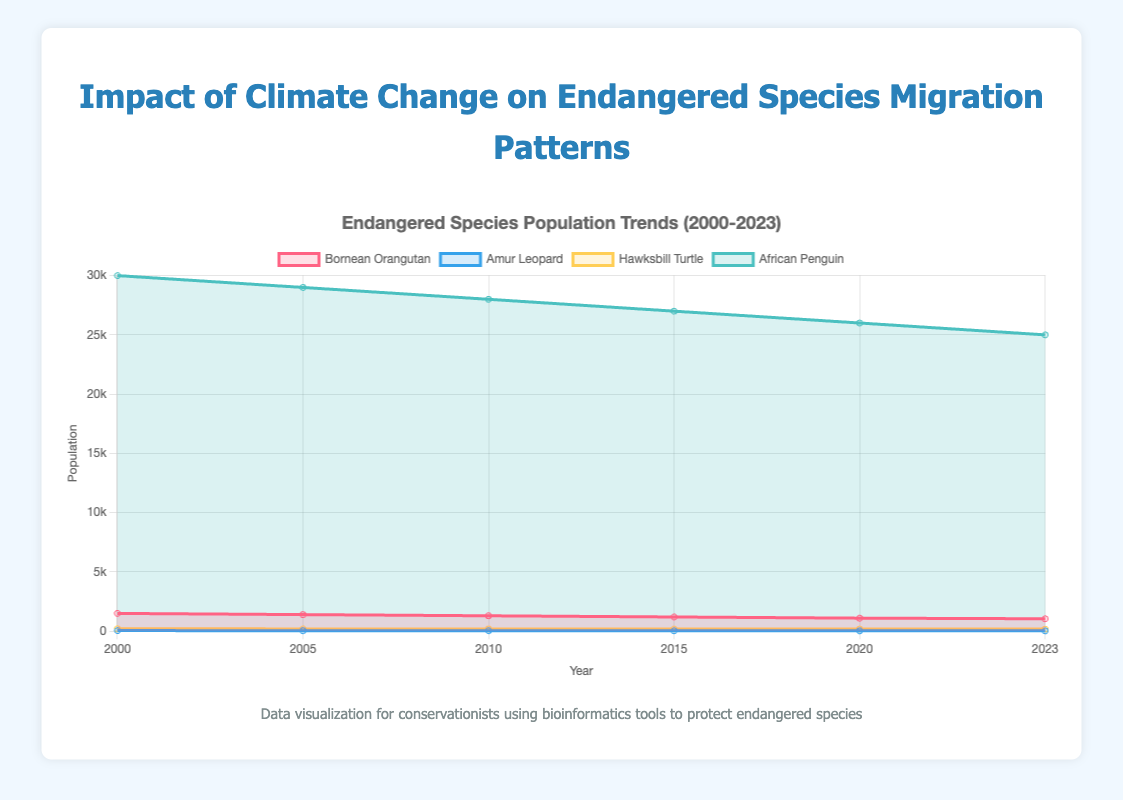What is the title of the figure? The title of the figure is prominently displayed at the top and indicates the main focus of the visualization.
Answer: Impact of Climate Change on Endangered Species Migration Patterns Which species has the highest population in 2020? By looking at the data series for 2020, the African Penguin has the highest population compared to the other species.
Answer: African Penguin What are the y-axis units in the figure? The y-axis units represent population counts as indicated by the numerical values along the axis.
Answer: Population How many data points are there for the Bornean Orangutan from 2000 to 2023? By counting the number of data points (years) available in the Bornean Orangutan dataset, there are six data points: 2000, 2005, 2010, 2015, 2020, 2023.
Answer: 6 Which species shows the largest decrease in population from 2000 to 2023? By comparing the population decreases for all species from 2000 to 2023, the African Penguin shows the largest reduction.
Answer: African Penguin What is the average population of the Amur Leopard over the years? The Amur Leopard population from 2000 to 2023 is given for six years. Summing these values (50+45+40+35+30+28) and dividing by 6 gives the average: (228 / 6) = 38.
Answer: 38 How does the population trend of the Hawksbill Turtle compare to the Amur Leopard from 2000 to 2023? Both species show a decreasing trend, but the Hawksbill Turtle has higher values throughout the period compared to the Amur Leopard.
Answer: Hawksbill Turtle higher What is the difference in the population of the Bornean Orangutan between the years 2000 and 2015? Subtracting the Bornean Orangutan population in 2015 from that in 2000: 1500 - 1200 = 300.
Answer: 300 Which species has the most stable population trends from 2000 to 2023? The smallest range of population changes is observed for the Amur Leopard, indicating it has the most stable trend compared to others.
Answer: Amur Leopard How are the species represented visually in the chart? Each species is represented by a distinct colored area, with labels for easy identification: Bornean Orangutan (red), Amur Leopard (blue), Hawksbill Turtle (yellow), and African Penguin (green).
Answer: Different colored areas 